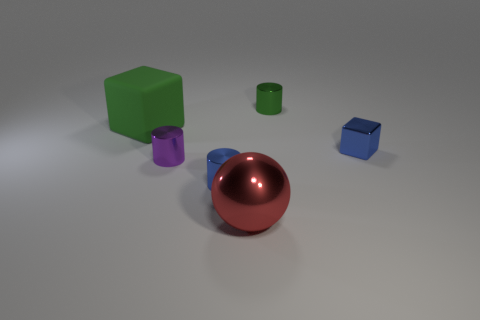Add 1 large blue rubber things. How many objects exist? 7 Subtract all cubes. How many objects are left? 4 Subtract 1 red spheres. How many objects are left? 5 Subtract all big cubes. Subtract all brown shiny cubes. How many objects are left? 5 Add 5 balls. How many balls are left? 6 Add 2 red spheres. How many red spheres exist? 3 